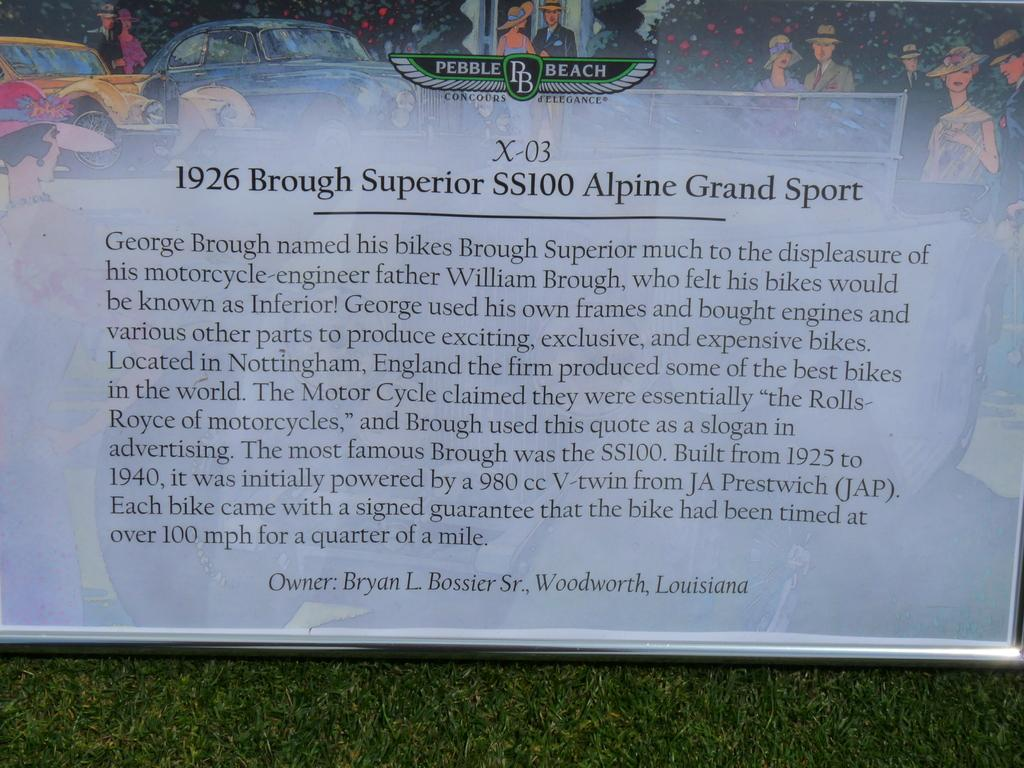What is hanging in the image? There is a banner in the image. What is depicted on the banner? The banner has a picture of cars. Can you describe the people in the image? There are people in the image, but their specific actions or appearances are not mentioned in the provided facts. What type of vegetation is present in the image? There are plants in the image. What is written at the bottom of the image? There is text written at the bottom of the image. Where is the banner placed? The banner is placed on the grass. What is the purpose of the eggnog in the image? There is no mention of eggnog in the image, so it cannot be determined if it has a purpose in the image. 